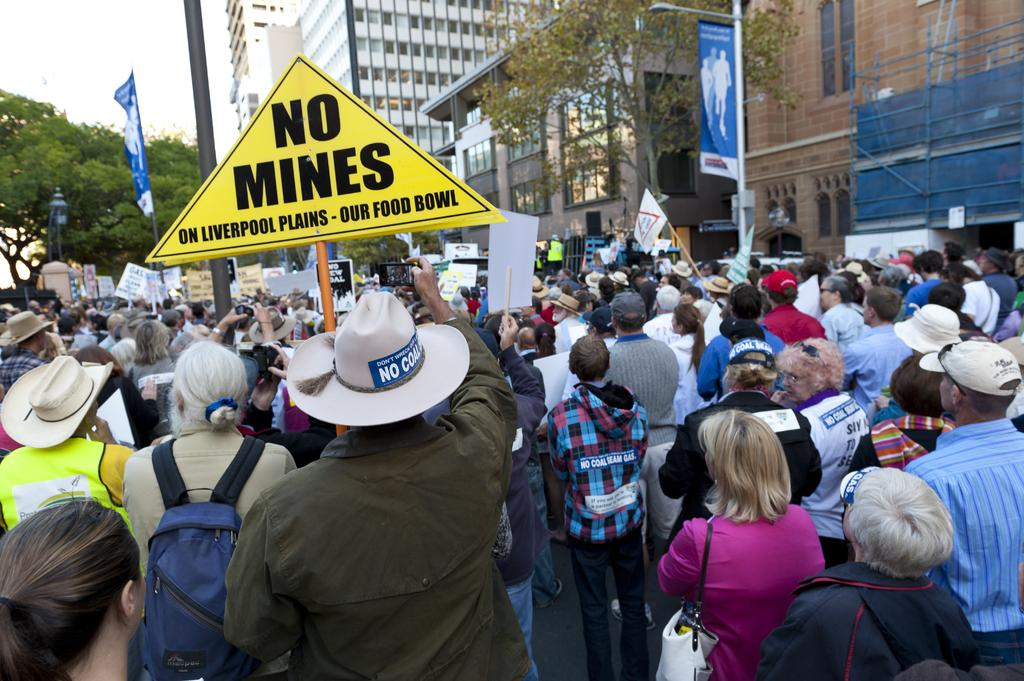What is the main subject of the image? The main subject of the image is a crowd of people. Can you describe the attire of some people in the crowd? Some people in the crowd are wearing hats. What else are some people in the crowd carrying? Some people in the crowd are carrying bags. What can be seen on a yellow board in the image? There is a yellow board with writing in the image. What is visible in the background of the image? In the background of the image, there are trees, buildings, and flags. How many robins can be seen perched on the flags in the image? There are no robins present in the image; it features a crowd of people with a background of trees, buildings, and flags. What type of rings are being exchanged in the image? There is no indication of any rings being exchanged in the image. 